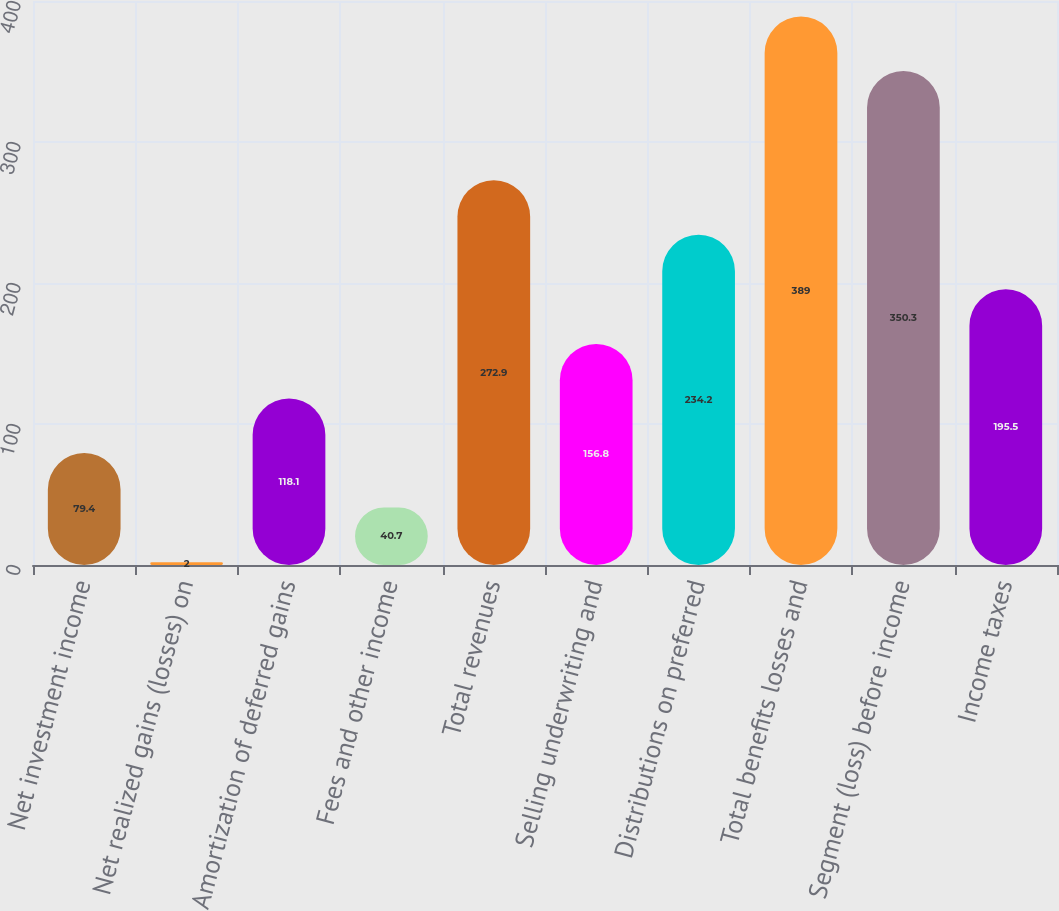Convert chart. <chart><loc_0><loc_0><loc_500><loc_500><bar_chart><fcel>Net investment income<fcel>Net realized gains (losses) on<fcel>Amortization of deferred gains<fcel>Fees and other income<fcel>Total revenues<fcel>Selling underwriting and<fcel>Distributions on preferred<fcel>Total benefits losses and<fcel>Segment (loss) before income<fcel>Income taxes<nl><fcel>79.4<fcel>2<fcel>118.1<fcel>40.7<fcel>272.9<fcel>156.8<fcel>234.2<fcel>389<fcel>350.3<fcel>195.5<nl></chart> 